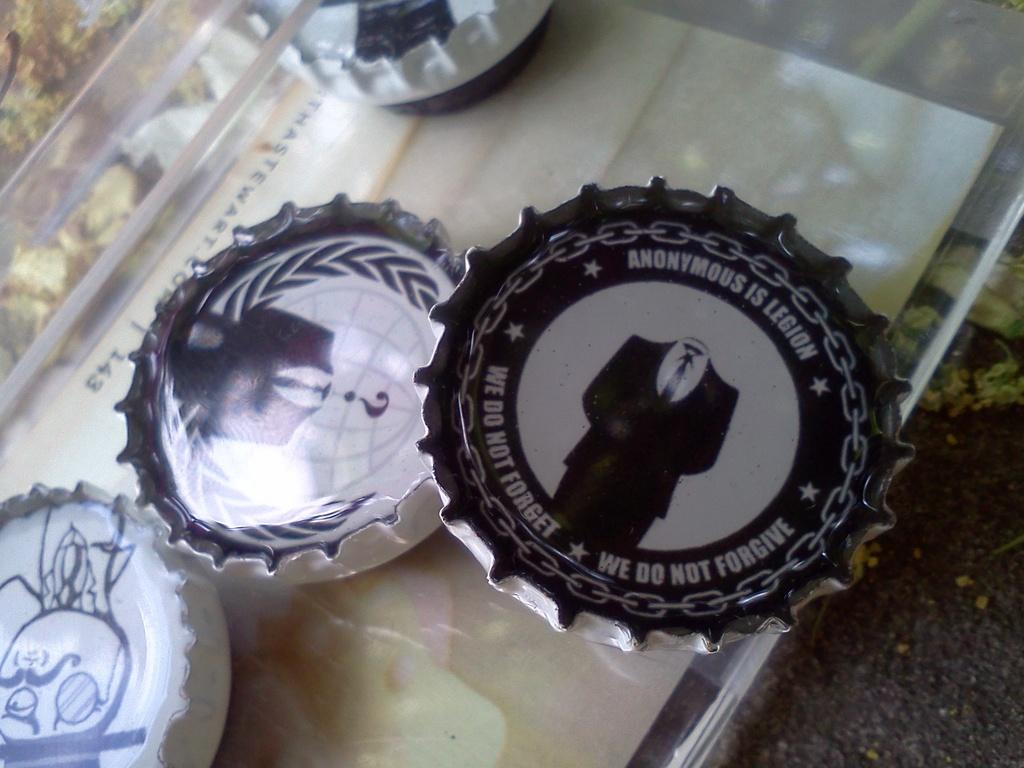How many bottle crowns are visible in the image? There are four bottle crowns in the image. What is located below the crowns? There are images below the crowns. On what surface are the crowns and images placed? The crowns and images are on a glass plate. What type of discovery was made by the yak in the image? There is no yak present in the image, so no discovery can be attributed to a yak. 